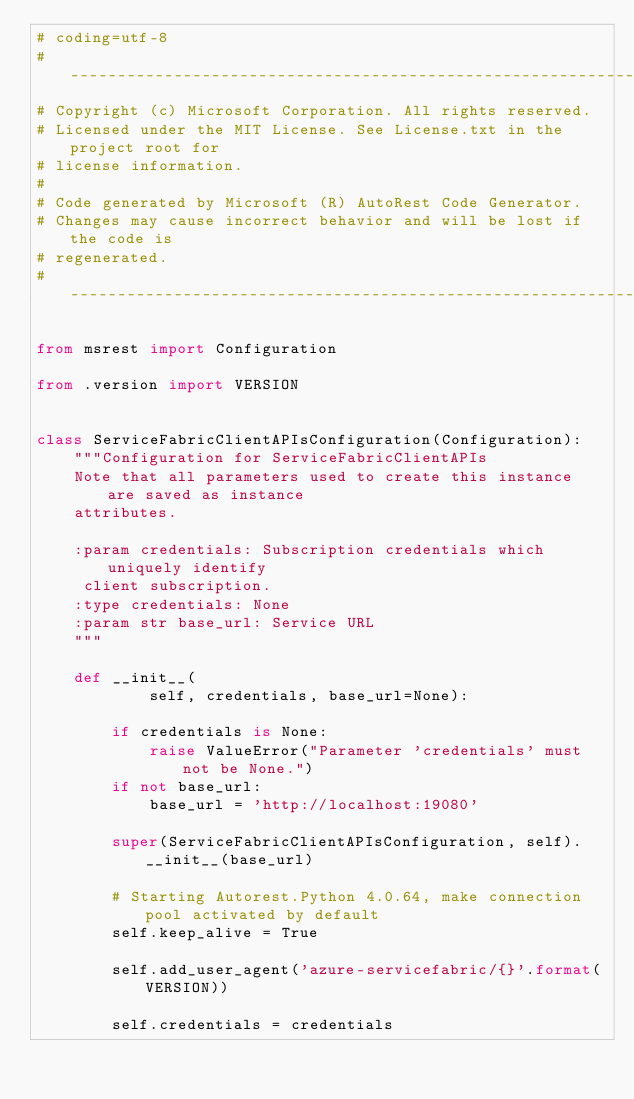Convert code to text. <code><loc_0><loc_0><loc_500><loc_500><_Python_># coding=utf-8
# --------------------------------------------------------------------------
# Copyright (c) Microsoft Corporation. All rights reserved.
# Licensed under the MIT License. See License.txt in the project root for
# license information.
#
# Code generated by Microsoft (R) AutoRest Code Generator.
# Changes may cause incorrect behavior and will be lost if the code is
# regenerated.
# --------------------------------------------------------------------------

from msrest import Configuration

from .version import VERSION


class ServiceFabricClientAPIsConfiguration(Configuration):
    """Configuration for ServiceFabricClientAPIs
    Note that all parameters used to create this instance are saved as instance
    attributes.

    :param credentials: Subscription credentials which uniquely identify
     client subscription.
    :type credentials: None
    :param str base_url: Service URL
    """

    def __init__(
            self, credentials, base_url=None):

        if credentials is None:
            raise ValueError("Parameter 'credentials' must not be None.")
        if not base_url:
            base_url = 'http://localhost:19080'

        super(ServiceFabricClientAPIsConfiguration, self).__init__(base_url)

        # Starting Autorest.Python 4.0.64, make connection pool activated by default
        self.keep_alive = True

        self.add_user_agent('azure-servicefabric/{}'.format(VERSION))

        self.credentials = credentials
</code> 